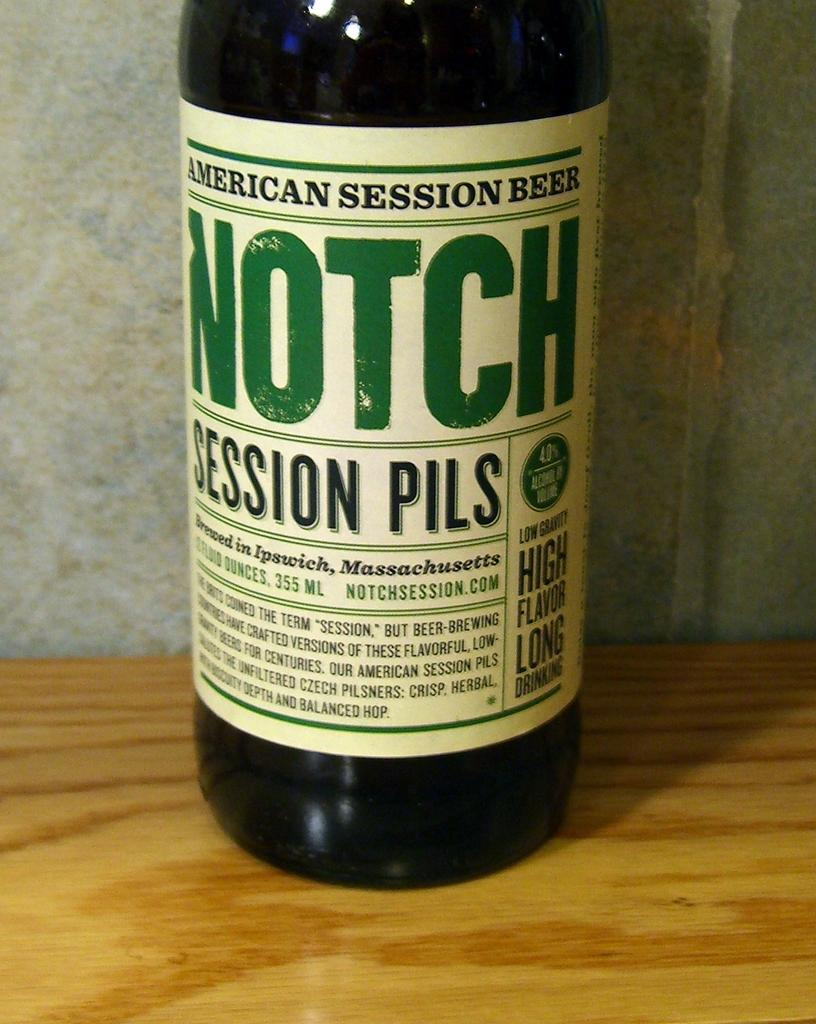<image>
Provide a brief description of the given image. A bottle of American Session Beer Notch sitting on a wooden surface. 